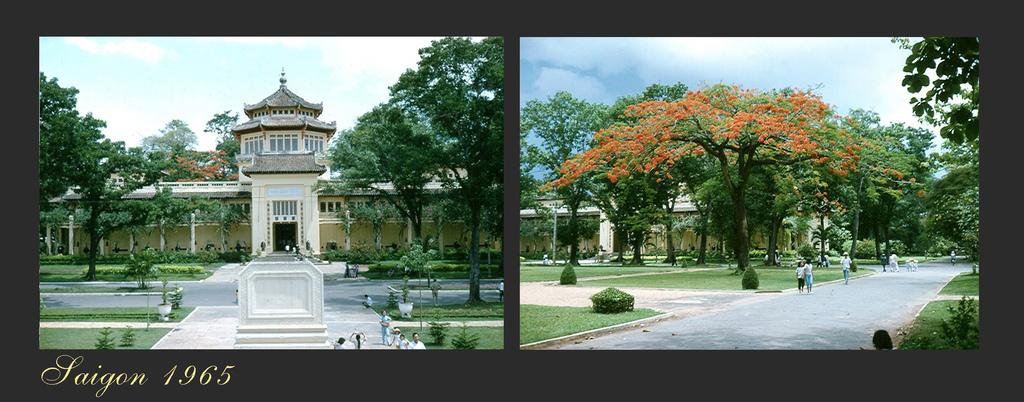What type of image is being described? The image is an edited collage. What structures can be seen in the image? There are buildings in the image. What type of vegetation is present in the image? There are plants, grass, and trees in the image. What other objects can be seen in the image? There are poles in the image. Are there any people in the image? Yes, there is a group of people standing in the image. What can be seen in the background of the image? The sky is visible in the image. Is there any indication that the image has been modified or shared? Yes, there is a watermark on the image. What type of polish is being applied to the mountain in the image? There is no mountain present in the image, and therefore no polish being applied. What type of quilt is being used to cover the trees in the image? There is no quilt present in the image, and the trees are not covered. 